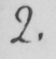Can you tell me what this handwritten text says? 2 . 